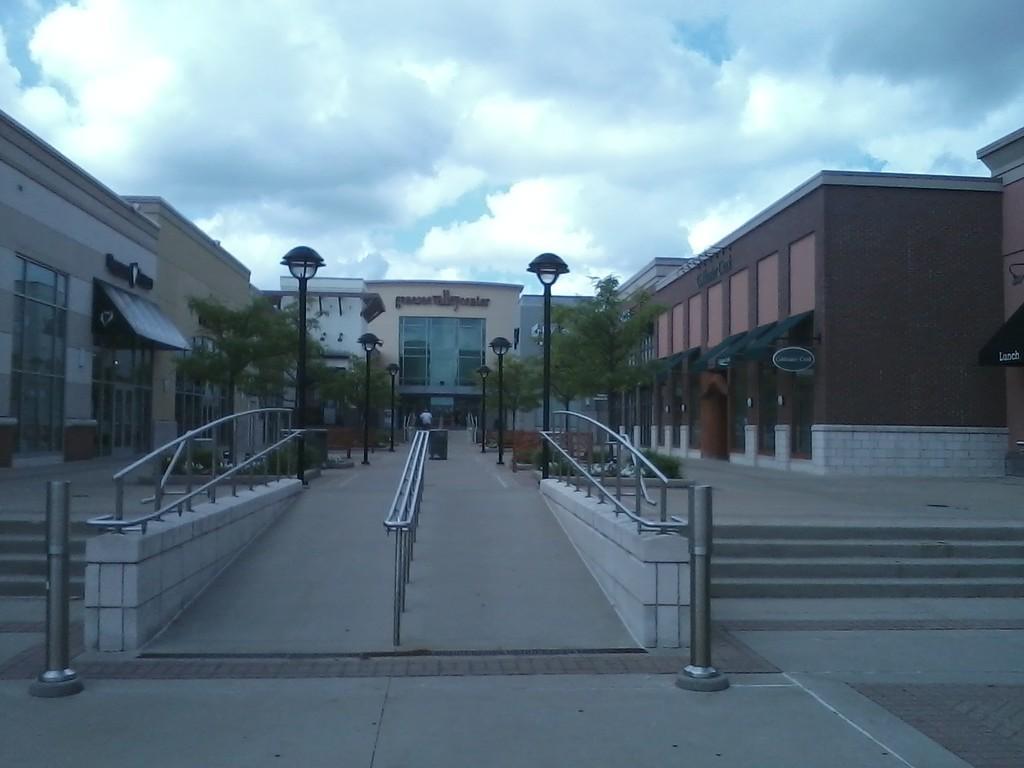Describe this image in one or two sentences. In this image I see number of buildings and I see the path and the steps and I see the railings and I see number of trees and I see the light poles. In the background I see the sky which is cloudy. 